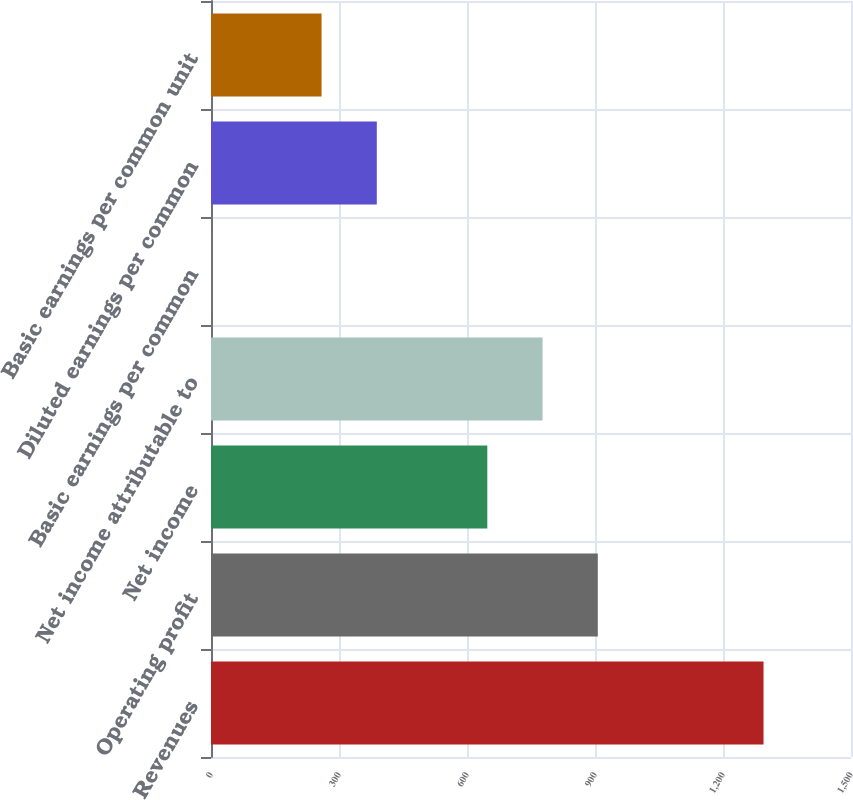Convert chart. <chart><loc_0><loc_0><loc_500><loc_500><bar_chart><fcel>Revenues<fcel>Operating profit<fcel>Net income<fcel>Net income attributable to<fcel>Basic earnings per common<fcel>Diluted earnings per common<fcel>Basic earnings per common unit<nl><fcel>1295<fcel>906.57<fcel>647.59<fcel>777.08<fcel>0.14<fcel>388.61<fcel>259.12<nl></chart> 